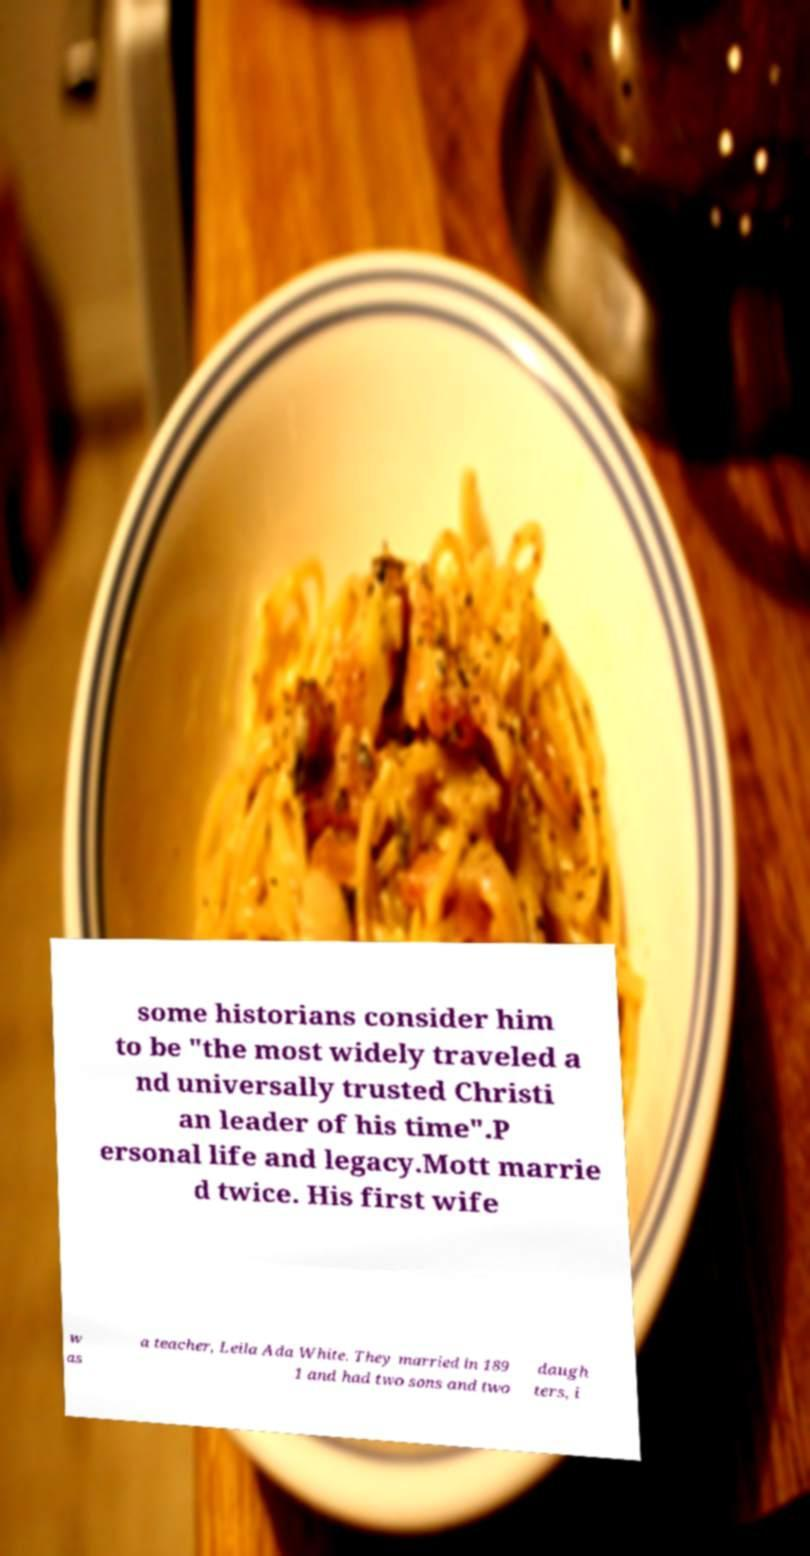Could you extract and type out the text from this image? some historians consider him to be "the most widely traveled a nd universally trusted Christi an leader of his time".P ersonal life and legacy.Mott marrie d twice. His first wife w as a teacher, Leila Ada White. They married in 189 1 and had two sons and two daugh ters, i 